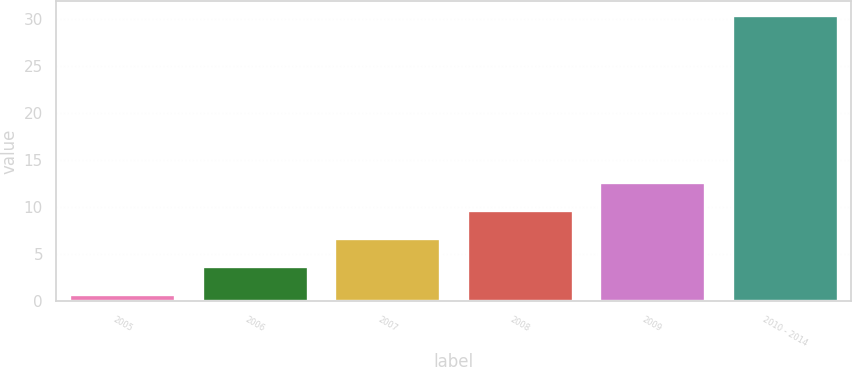Convert chart to OTSL. <chart><loc_0><loc_0><loc_500><loc_500><bar_chart><fcel>2005<fcel>2006<fcel>2007<fcel>2008<fcel>2009<fcel>2010 - 2014<nl><fcel>0.8<fcel>3.76<fcel>6.72<fcel>9.68<fcel>12.64<fcel>30.4<nl></chart> 